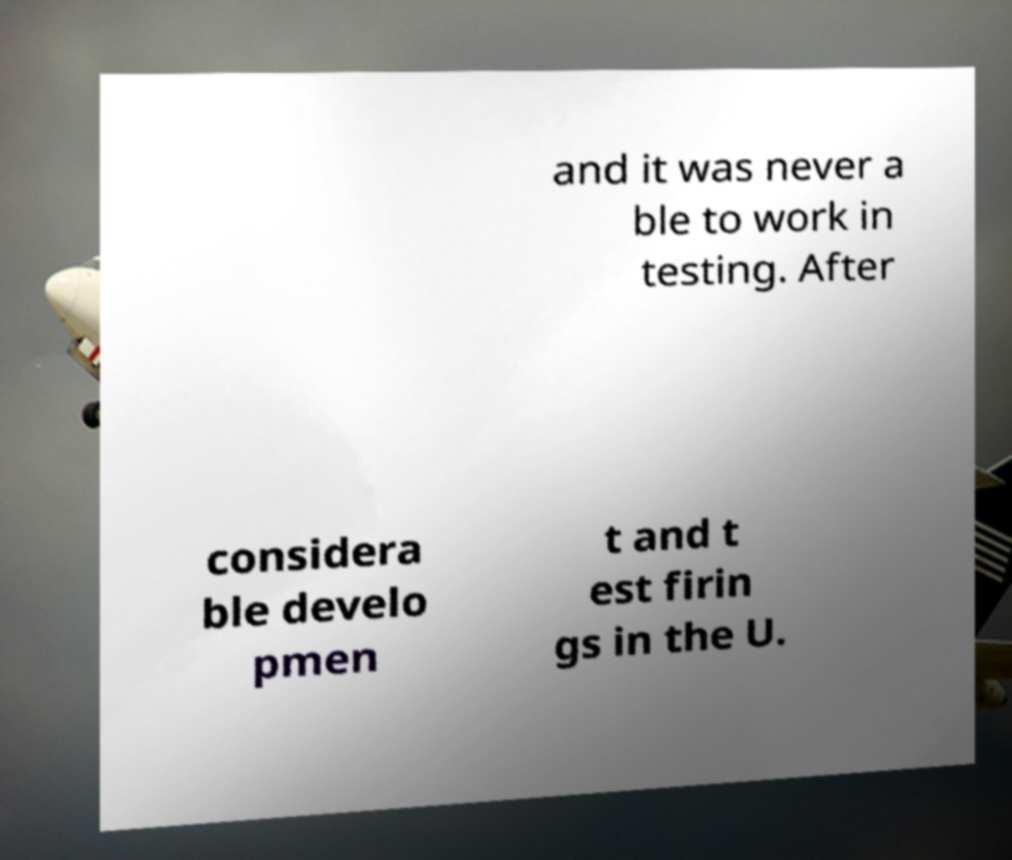Can you accurately transcribe the text from the provided image for me? and it was never a ble to work in testing. After considera ble develo pmen t and t est firin gs in the U. 